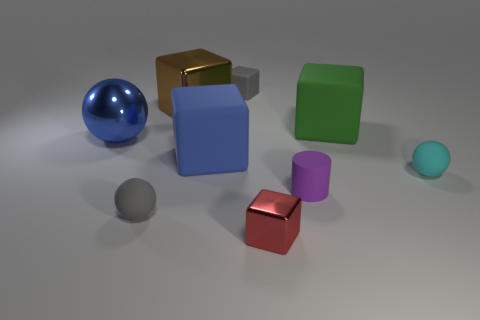Can you describe the texture differences between the objects? Certainly, the blue and mint spheres appear smooth and glossy, indicative of a reflective plastic or glass material. The cubes display different textures; the green one seems matte, likely plastic; the red cube appears metallic and reflective; and the brown one looks like polished metal, while the gray and purple objects have a more subdued, rougher texture, resembling stone or frosted glass. 